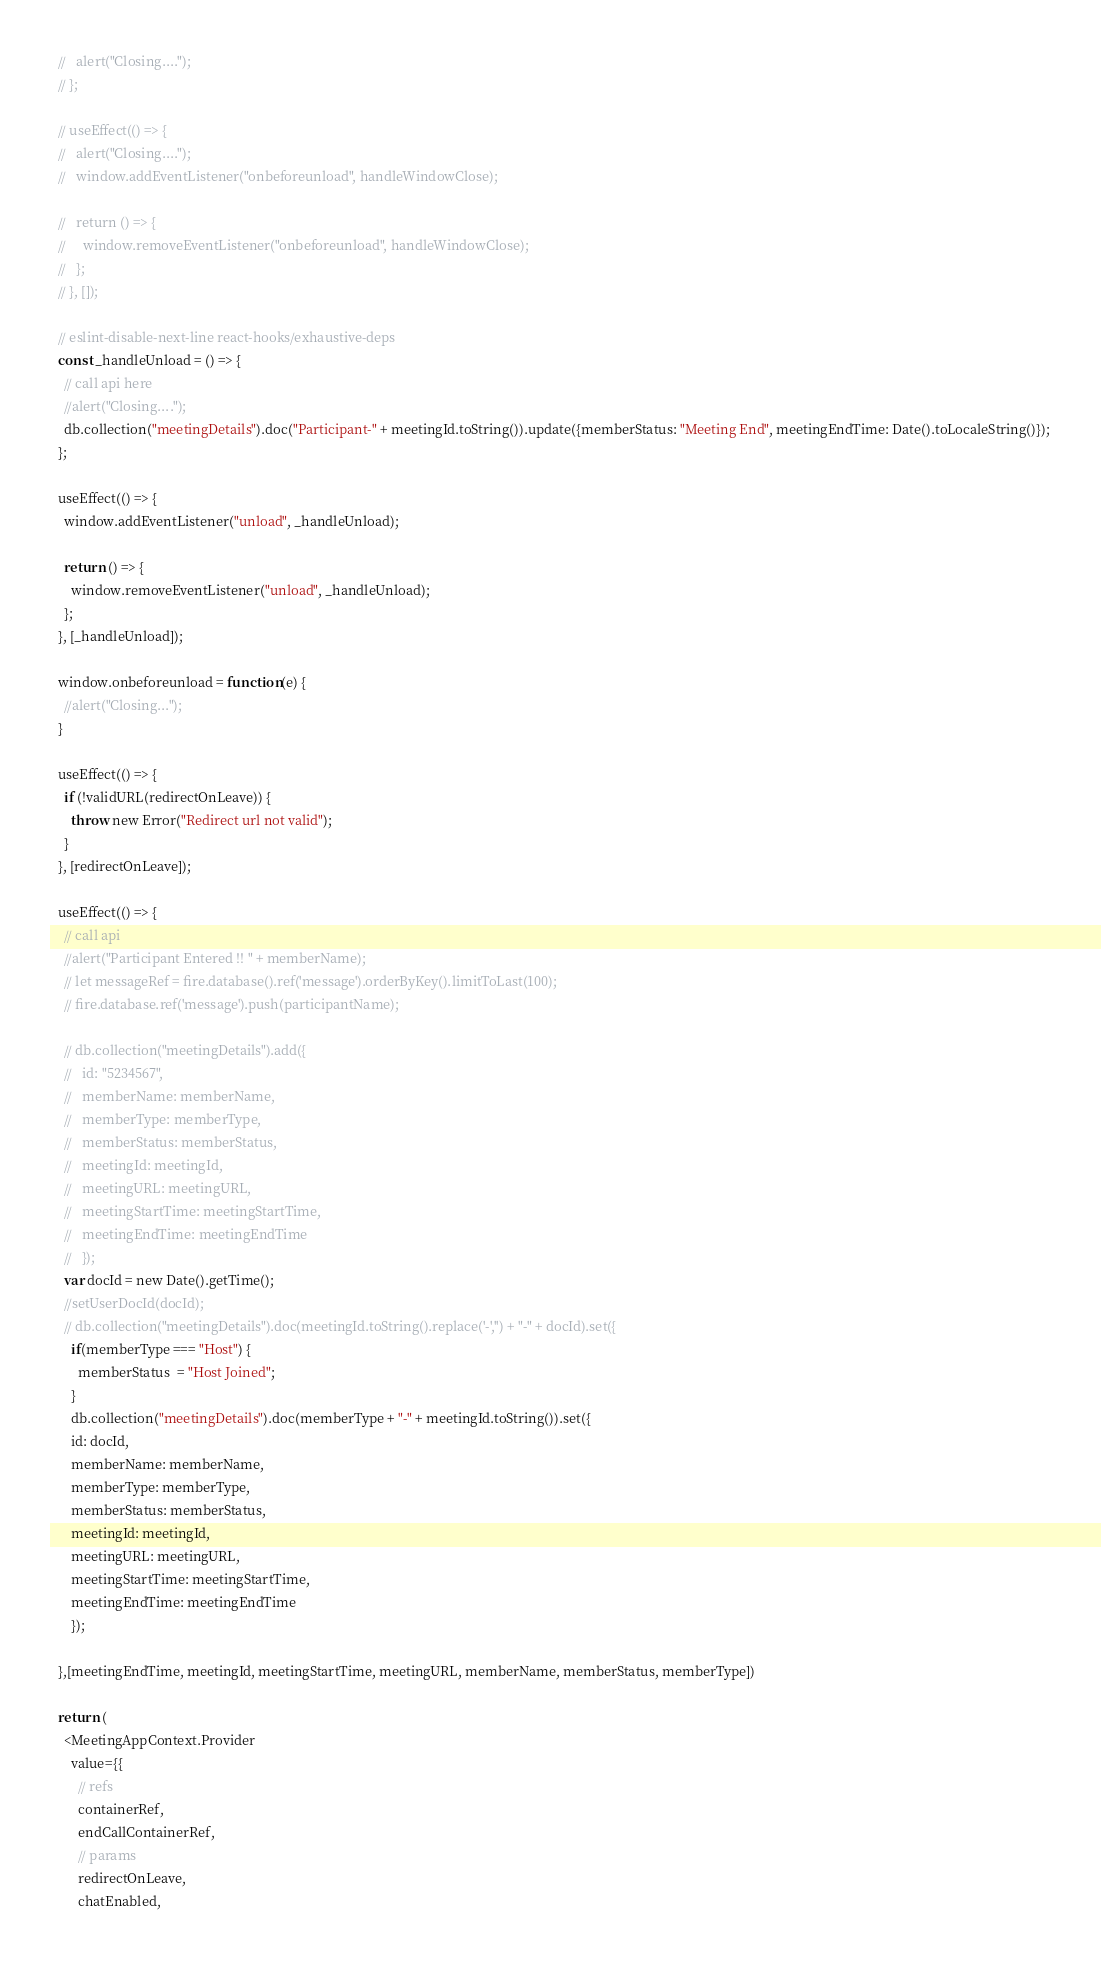<code> <loc_0><loc_0><loc_500><loc_500><_JavaScript_>  //   alert("Closing....");
  // };

  // useEffect(() => {
  //   alert("Closing....");
  //   window.addEventListener("onbeforeunload", handleWindowClose);

  //   return () => {
  //     window.removeEventListener("onbeforeunload", handleWindowClose);
  //   };
  // }, []);

  // eslint-disable-next-line react-hooks/exhaustive-deps
  const _handleUnload = () => {
    // call api here
    //alert("Closing....");
    db.collection("meetingDetails").doc("Participant-" + meetingId.toString()).update({memberStatus: "Meeting End", meetingEndTime: Date().toLocaleString()});
  };

  useEffect(() => {
    window.addEventListener("unload", _handleUnload);

    return () => {
      window.removeEventListener("unload", _handleUnload);
    };
  }, [_handleUnload]);

  window.onbeforeunload = function(e) {
    //alert("Closing...");
  }

  useEffect(() => {
    if (!validURL(redirectOnLeave)) {
      throw new Error("Redirect url not valid");
    }
  }, [redirectOnLeave]);

  useEffect(() => {
    // call api 
    //alert("Participant Entered !! " + memberName);
    // let messageRef = fire.database().ref('message').orderByKey().limitToLast(100);
    // fire.database.ref('message').push(participantName);

    // db.collection("meetingDetails").add({
    //   id: "5234567",
    //   memberName: memberName,
    //   memberType: memberType,
    //   memberStatus: memberStatus,
    //   meetingId: meetingId,
    //   meetingURL: meetingURL,
    //   meetingStartTime: meetingStartTime,
    //   meetingEndTime: meetingEndTime
    //   });
    var docId = new Date().getTime();
    //setUserDocId(docId);
    // db.collection("meetingDetails").doc(meetingId.toString().replace('-','') + "-" + docId).set({
      if(memberType === "Host") {
        memberStatus  = "Host Joined";
      }
      db.collection("meetingDetails").doc(memberType + "-" + meetingId.toString()).set({
      id: docId,
      memberName: memberName,
      memberType: memberType,
      memberStatus: memberStatus,
      meetingId: meetingId,
      meetingURL: meetingURL,
      meetingStartTime: meetingStartTime,
      meetingEndTime: meetingEndTime
      });

  },[meetingEndTime, meetingId, meetingStartTime, meetingURL, memberName, memberStatus, memberType])

  return (
    <MeetingAppContext.Provider
      value={{
        // refs
        containerRef,
        endCallContainerRef,
        // params
        redirectOnLeave,
        chatEnabled,</code> 